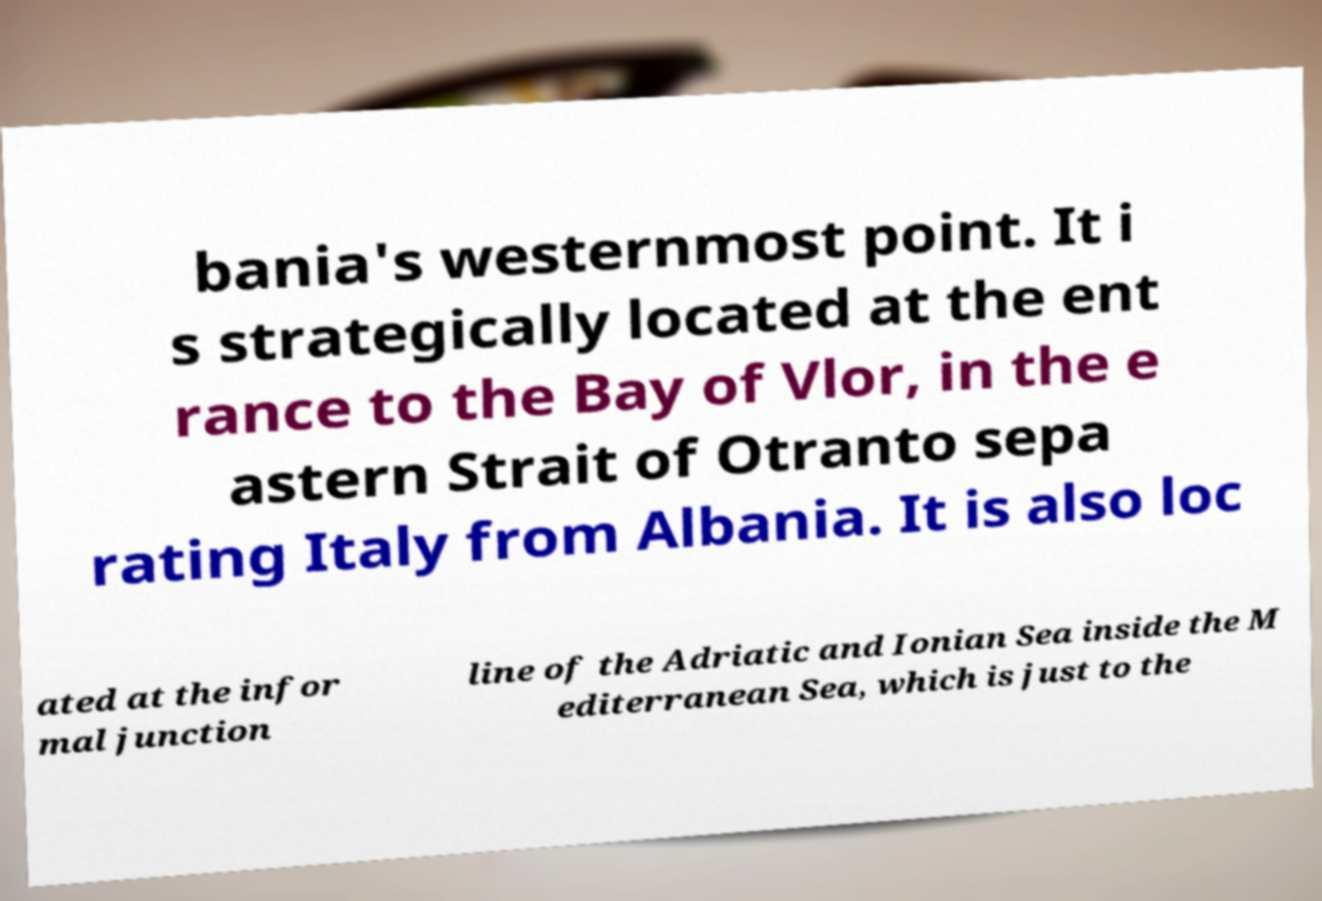Please identify and transcribe the text found in this image. bania's westernmost point. It i s strategically located at the ent rance to the Bay of Vlor, in the e astern Strait of Otranto sepa rating Italy from Albania. It is also loc ated at the infor mal junction line of the Adriatic and Ionian Sea inside the M editerranean Sea, which is just to the 